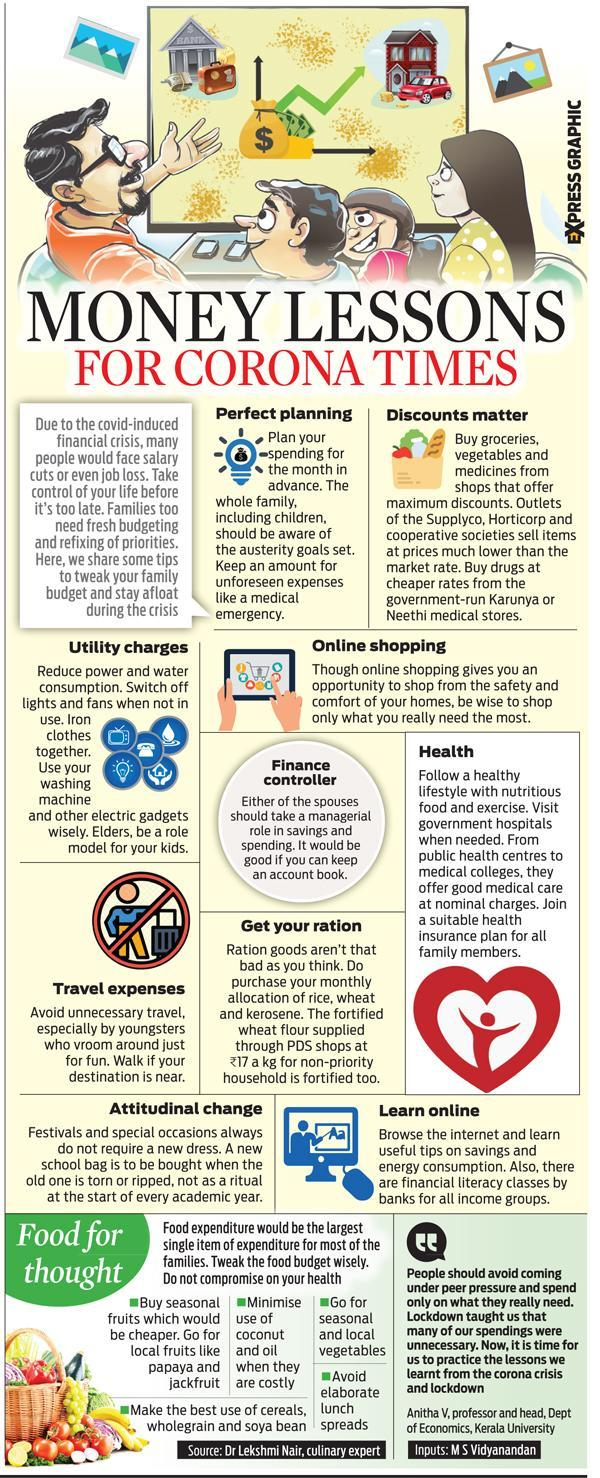Specify some key components in this picture. This infographic mentions 2 local fruits. 